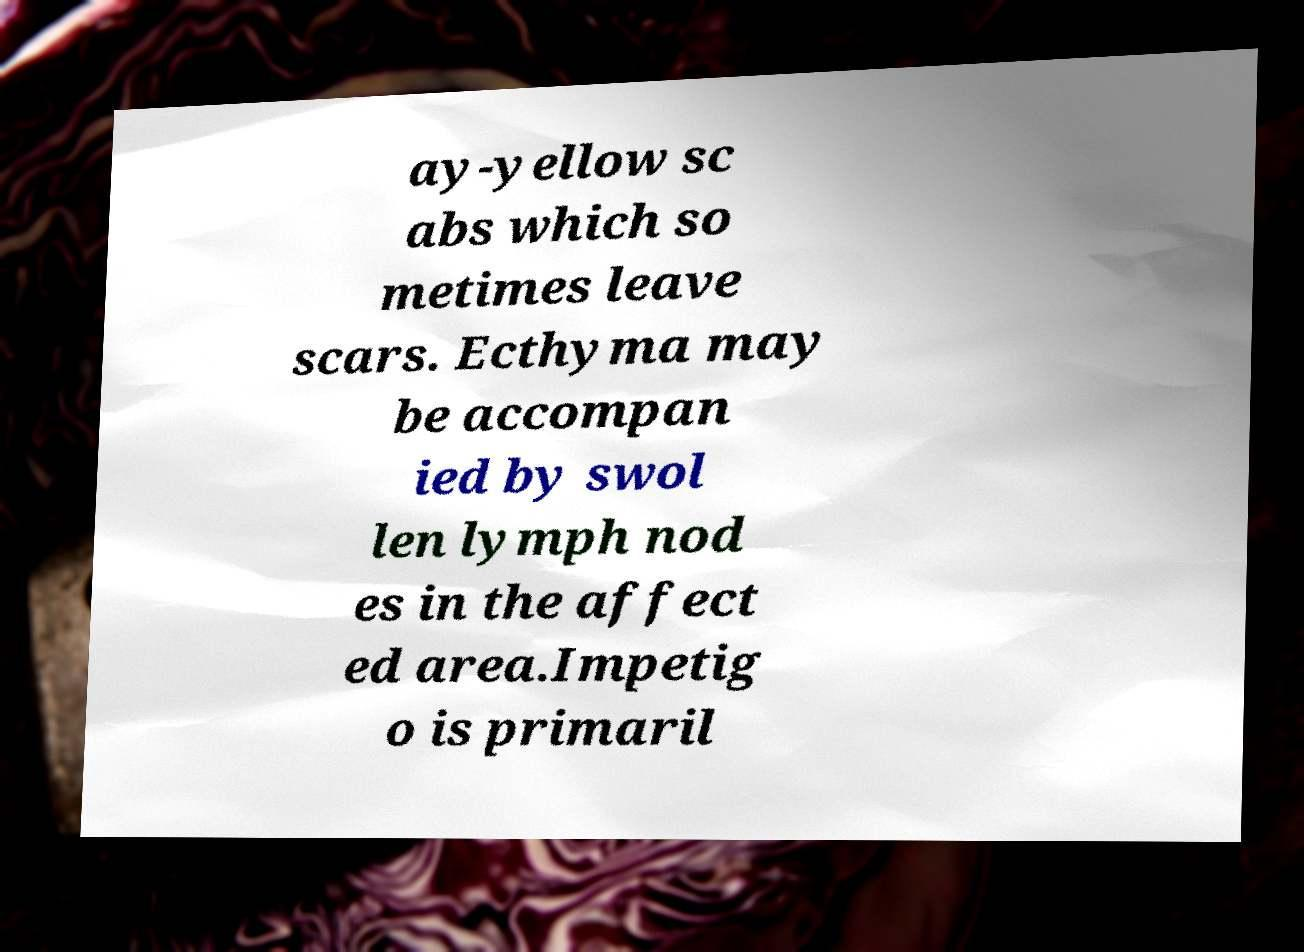Please read and relay the text visible in this image. What does it say? ay-yellow sc abs which so metimes leave scars. Ecthyma may be accompan ied by swol len lymph nod es in the affect ed area.Impetig o is primaril 